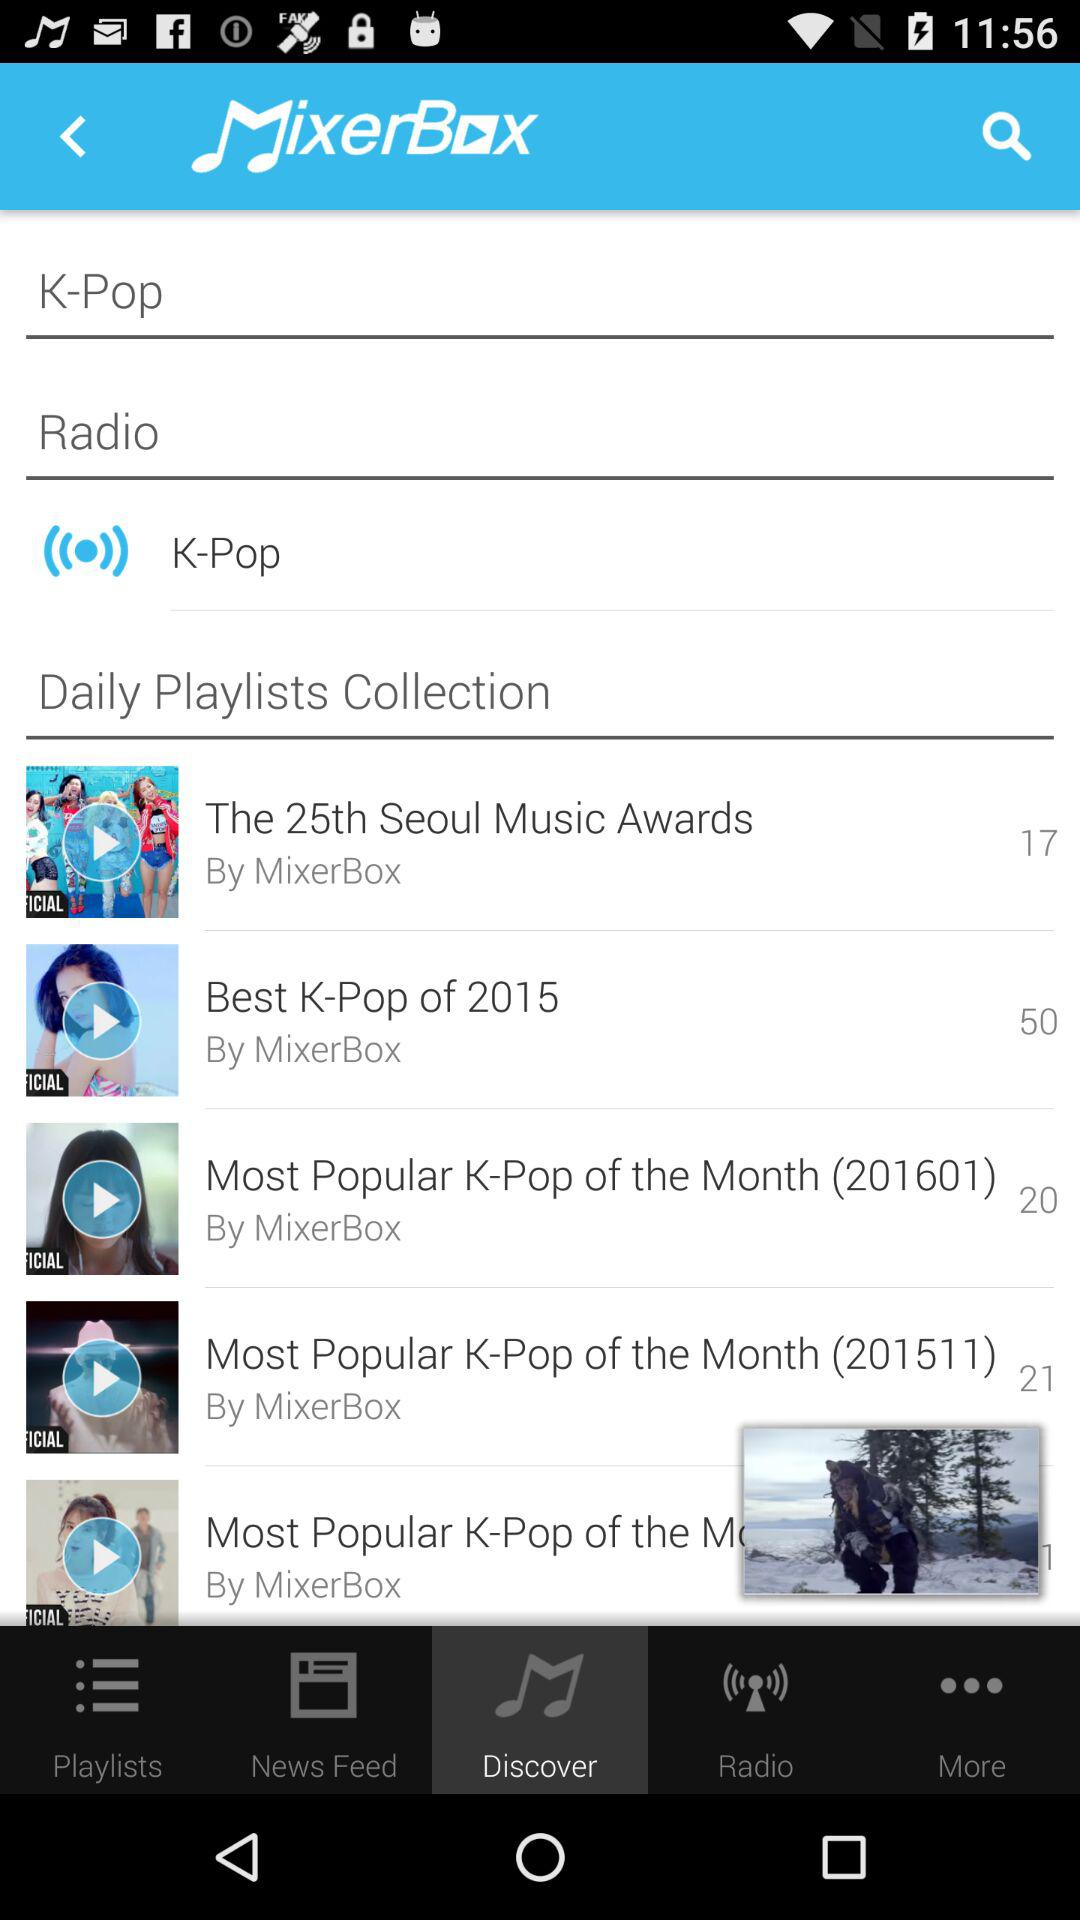What is the singer name of the 25th Seoul music awards song?
When the provided information is insufficient, respond with <no answer>. <no answer> 